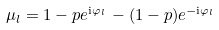<formula> <loc_0><loc_0><loc_500><loc_500>\mu _ { l } = 1 - p e ^ { \text {i} \varphi _ { l } \, } - ( 1 - p ) e ^ { - \text {i} \varphi _ { l } }</formula> 